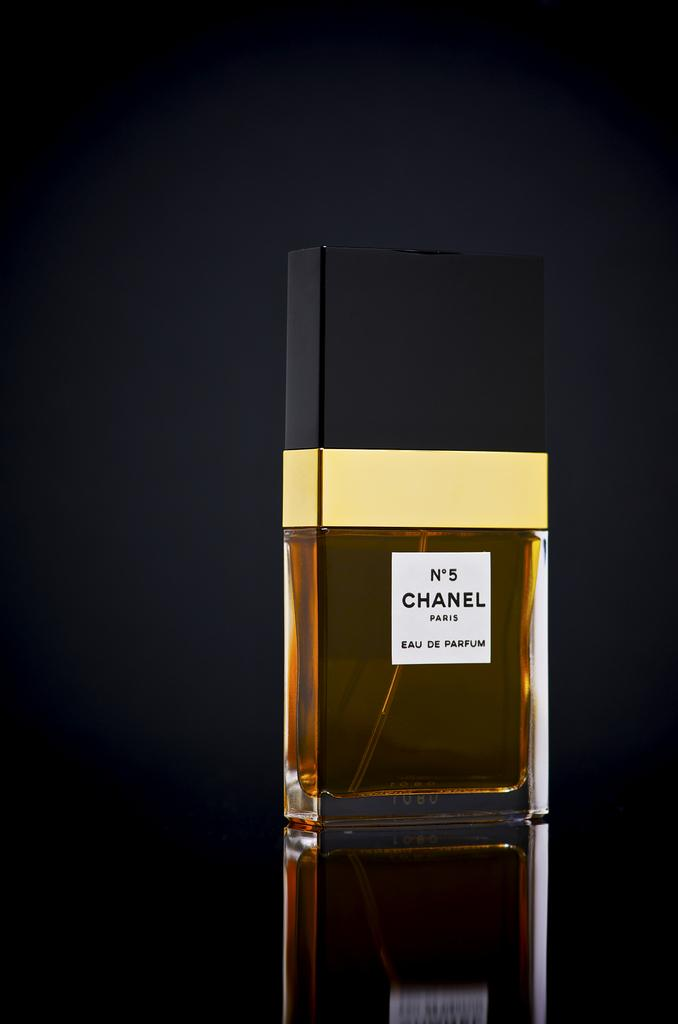<image>
Describe the image concisely. Chanel N.5 is expensive yet popular perfume that many people enjoy. 